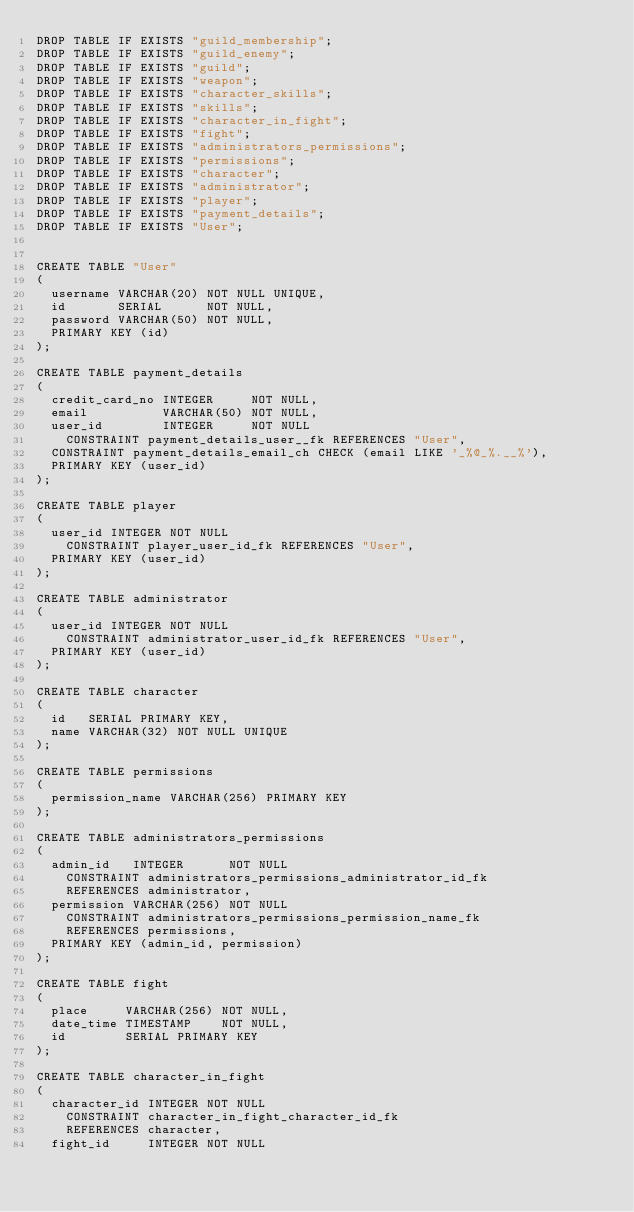Convert code to text. <code><loc_0><loc_0><loc_500><loc_500><_SQL_>DROP TABLE IF EXISTS "guild_membership";
DROP TABLE IF EXISTS "guild_enemy";
DROP TABLE IF EXISTS "guild";
DROP TABLE IF EXISTS "weapon";
DROP TABLE IF EXISTS "character_skills";
DROP TABLE IF EXISTS "skills";
DROP TABLE IF EXISTS "character_in_fight";
DROP TABLE IF EXISTS "fight";
DROP TABLE IF EXISTS "administrators_permissions";
DROP TABLE IF EXISTS "permissions";
DROP TABLE IF EXISTS "character";
DROP TABLE IF EXISTS "administrator";
DROP TABLE IF EXISTS "player";
DROP TABLE IF EXISTS "payment_details";
DROP TABLE IF EXISTS "User";


CREATE TABLE "User"
(
  username VARCHAR(20) NOT NULL UNIQUE,
  id       SERIAL      NOT NULL,
  password VARCHAR(50) NOT NULL,
  PRIMARY KEY (id)
);

CREATE TABLE payment_details
(
  credit_card_no INTEGER     NOT NULL,
  email          VARCHAR(50) NOT NULL,
  user_id        INTEGER     NOT NULL
    CONSTRAINT payment_details_user__fk REFERENCES "User",
  CONSTRAINT payment_details_email_ch CHECK (email LIKE '_%@_%.__%'),
  PRIMARY KEY (user_id)
);

CREATE TABLE player
(
  user_id INTEGER NOT NULL
    CONSTRAINT player_user_id_fk REFERENCES "User",
  PRIMARY KEY (user_id)
);

CREATE TABLE administrator
(
  user_id INTEGER NOT NULL
    CONSTRAINT administrator_user_id_fk REFERENCES "User",
  PRIMARY KEY (user_id)
);

CREATE TABLE character
(
  id   SERIAL PRIMARY KEY,
  name VARCHAR(32) NOT NULL UNIQUE
);

CREATE TABLE permissions
(
  permission_name VARCHAR(256) PRIMARY KEY
);

CREATE TABLE administrators_permissions
(
  admin_id   INTEGER      NOT NULL
    CONSTRAINT administrators_permissions_administrator_id_fk
    REFERENCES administrator,
  permission VARCHAR(256) NOT NULL
    CONSTRAINT administrators_permissions_permission_name_fk
    REFERENCES permissions,
  PRIMARY KEY (admin_id, permission)
);

CREATE TABLE fight
(
  place     VARCHAR(256) NOT NULL,
  date_time TIMESTAMP    NOT NULL,
  id        SERIAL PRIMARY KEY
);

CREATE TABLE character_in_fight
(
  character_id INTEGER NOT NULL
    CONSTRAINT character_in_fight_character_id_fk
    REFERENCES character,
  fight_id     INTEGER NOT NULL</code> 